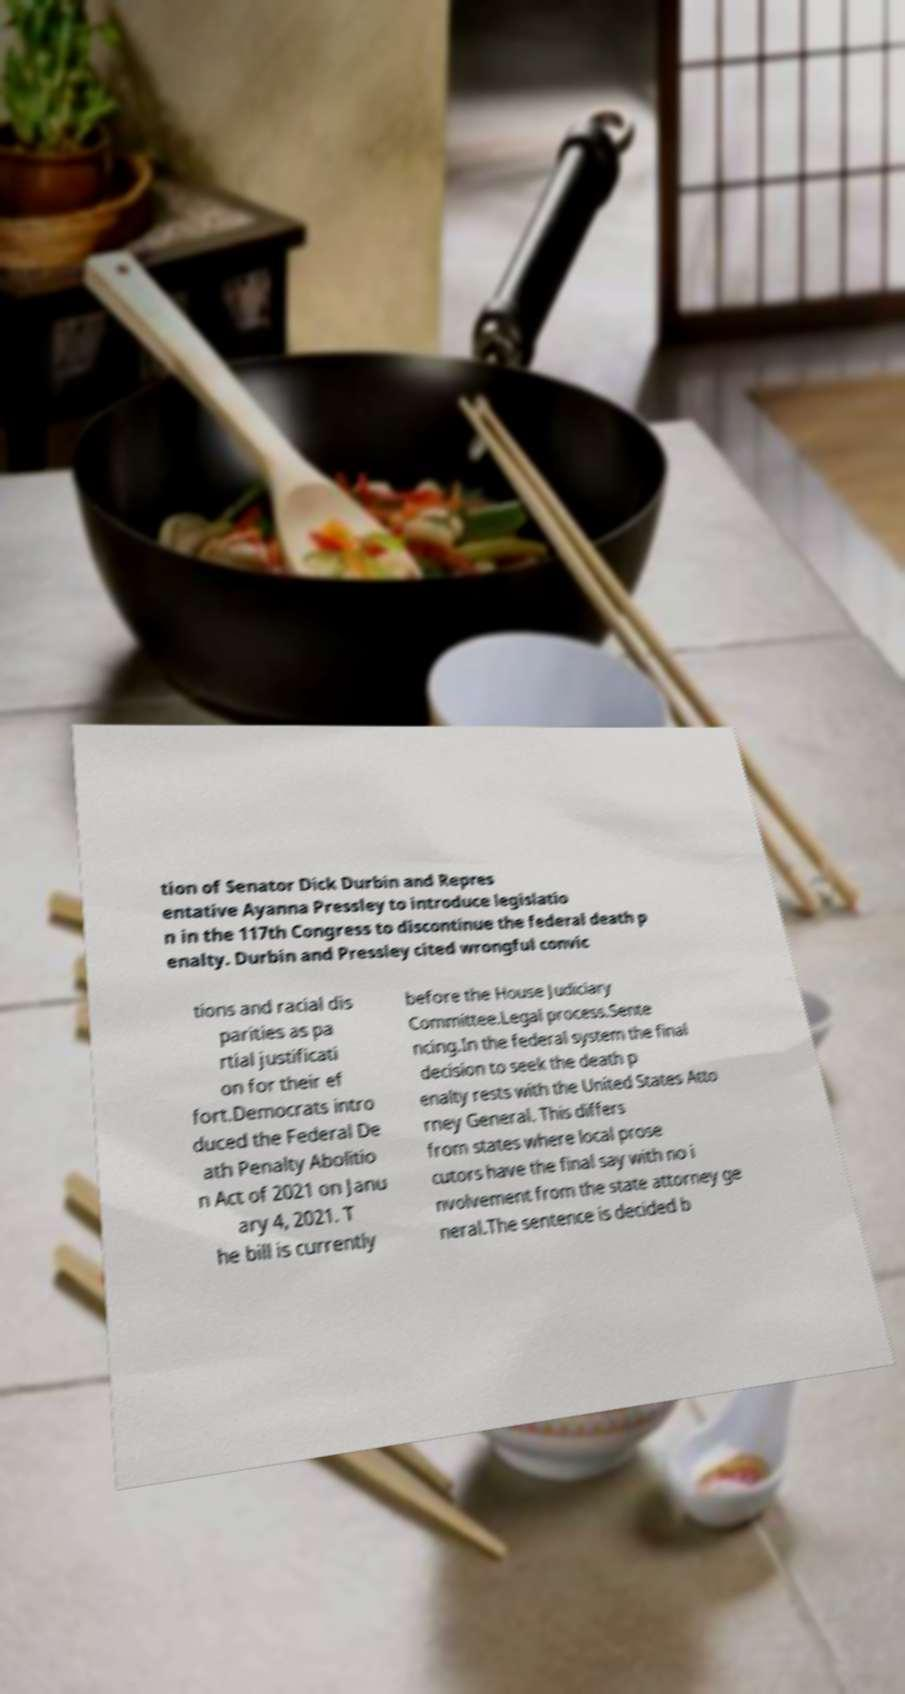There's text embedded in this image that I need extracted. Can you transcribe it verbatim? tion of Senator Dick Durbin and Repres entative Ayanna Pressley to introduce legislatio n in the 117th Congress to discontinue the federal death p enalty. Durbin and Pressley cited wrongful convic tions and racial dis parities as pa rtial justificati on for their ef fort.Democrats intro duced the Federal De ath Penalty Abolitio n Act of 2021 on Janu ary 4, 2021. T he bill is currently before the House Judiciary Committee.Legal process.Sente ncing.In the federal system the final decision to seek the death p enalty rests with the United States Atto rney General. This differs from states where local prose cutors have the final say with no i nvolvement from the state attorney ge neral.The sentence is decided b 